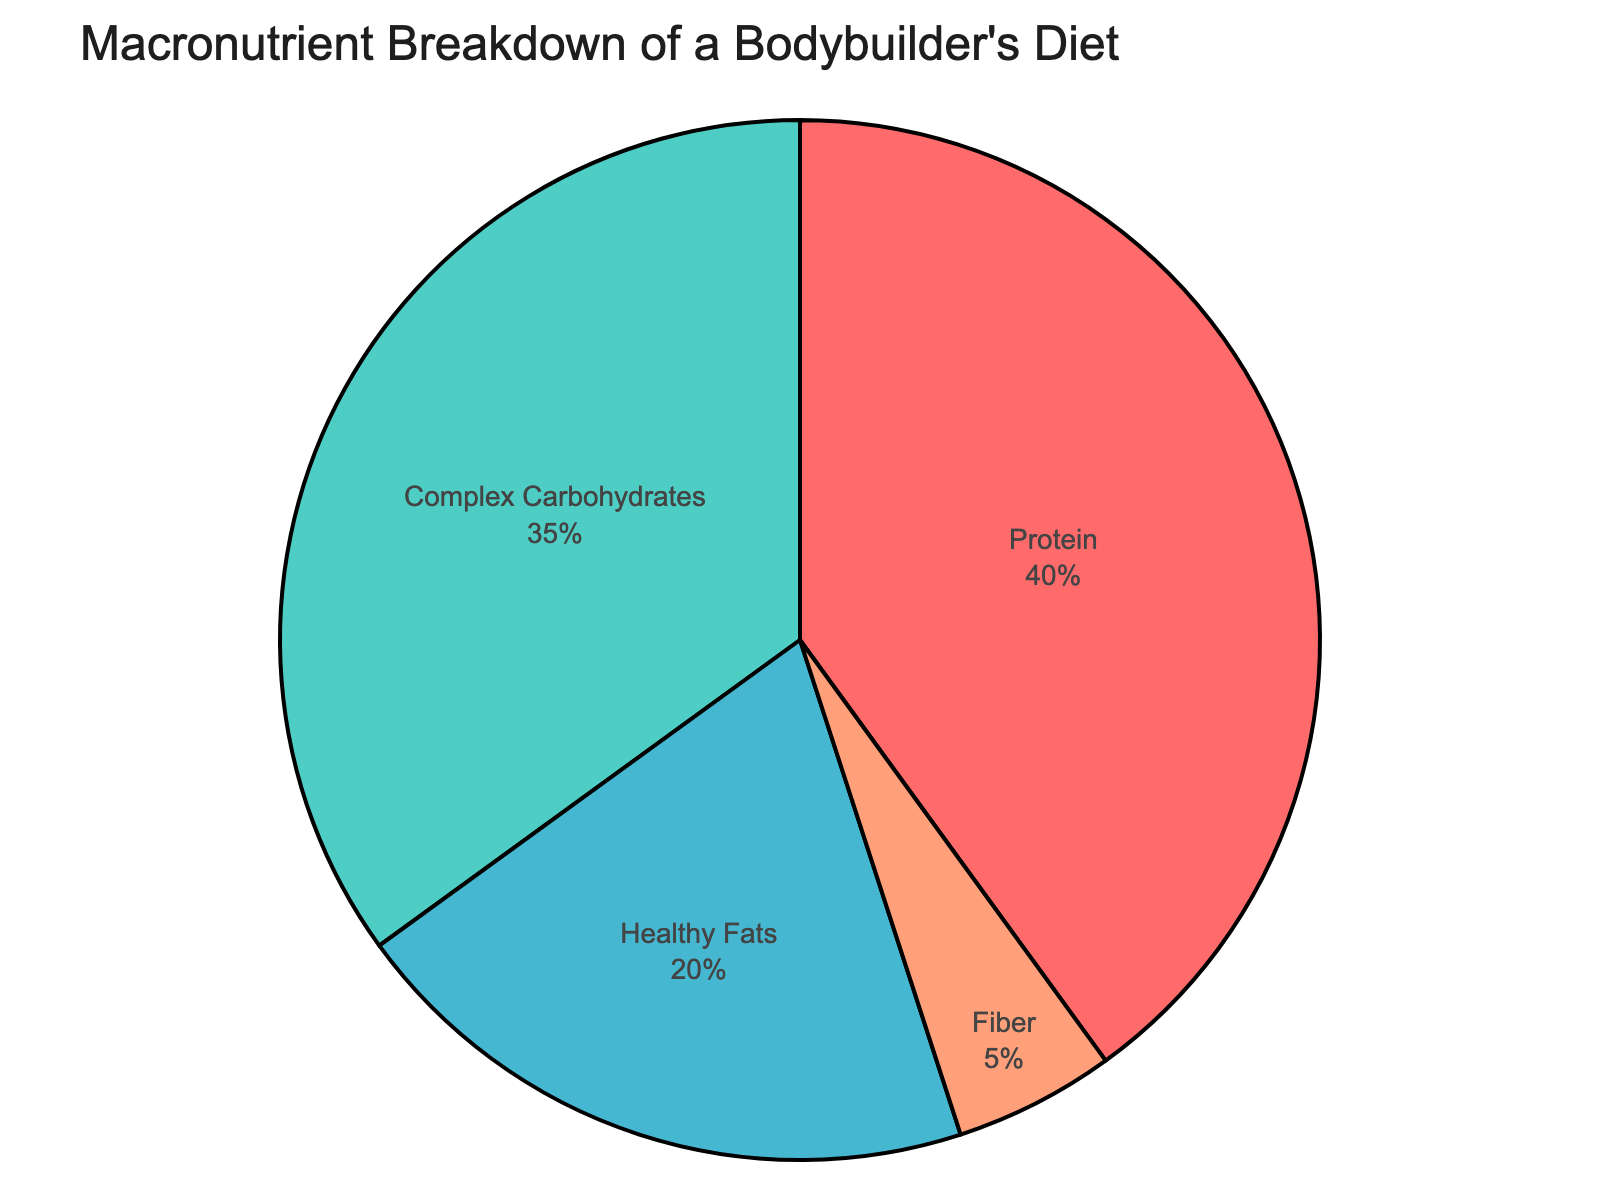Which macronutrient has the highest percentage in the diet? Look at the pie chart and identify the segment with the largest area. It's labeled "Protein" with 40%.
Answer: Protein Which macronutrient makes up the smallest portion of the diet? Look at the pie chart and locate the smallest segment. It's labeled "Fiber" with 5%.
Answer: Fiber How much higher is the percentage of Complex Carbohydrates compared to Healthy Fats? Subtract the percentage of Healthy Fats (20%) from the percentage of Complex Carbohydrates (35%): 35% - 20% = 15%.
Answer: 15% What's the total percentage of Protein and Healthy Fats combined? Add the percentage of Protein (40%) and Healthy Fats (20%): 40% + 20% = 60%.
Answer: 60% If you consider only Protein and Complex Carbohydrates, what percentage of the total diet do they represent? Add the percentage of Protein (40%) and Complex Carbohydrates (35%): 40% + 35% = 75%.
Answer: 75% Which two macronutrients together account for less than half of the total percentage? Add the percentages of each possible pair and find those which sum to less than 50%. The pairs are Healthy Fats (20%) + Fiber (5%) = 25%, and Complex Carbohydrates (35%) + Fiber (5%) = 40%.
Answer: Healthy Fats and Fiber What is the difference in percentage between the largest and smallest macronutrient categories? Subtract the Fiber percentage (5%) from the Protein percentage (40%): 40% - 5% = 35%.
Answer: 35% Do Protein and Fiber together make up more than half of the bodybuilder's diet? Add the percentage of Protein (40%) and Fiber (5%): 40% + 5% = 45%, which is less than 50%.
Answer: No If you combine Healthy Fats and Fiber, does their combined percentage exceed that of Complex Carbohydrates? Add the percentages of Healthy Fats (20%) and Fiber (5%) to get 25%, which is less than the percentage of Complex Carbohydrates (35%).
Answer: No 